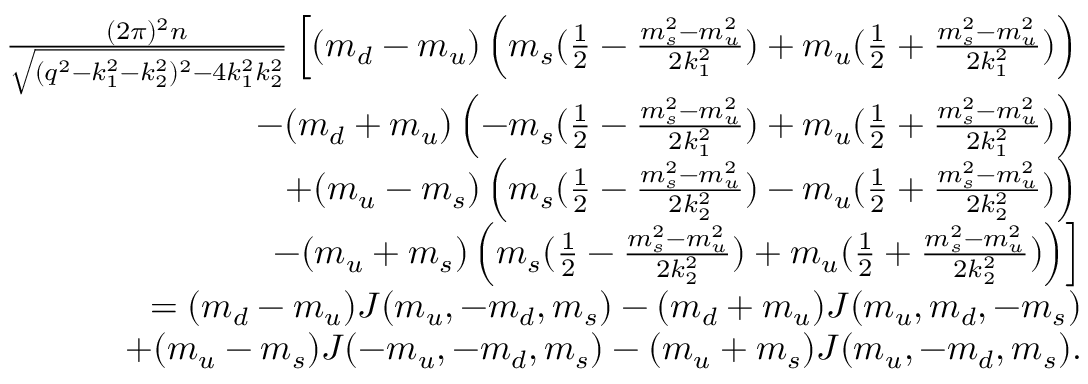<formula> <loc_0><loc_0><loc_500><loc_500>\begin{array} { r l r } & { \frac { ( 2 \pi ) ^ { 2 } n } { \sqrt { ( q ^ { 2 } - k _ { 1 } ^ { 2 } - k _ { 2 } ^ { 2 } ) ^ { 2 } - 4 k _ { 1 } ^ { 2 } k _ { 2 } ^ { 2 } } } \left [ ( m _ { d } - m _ { u } ) \left ( m _ { s } ( \frac { 1 } { 2 } - \frac { m _ { s } ^ { 2 } - m _ { u } ^ { 2 } } { 2 k _ { 1 } ^ { 2 } } ) + m _ { u } ( \frac { 1 } { 2 } + \frac { m _ { s } ^ { 2 } - m _ { u } ^ { 2 } } { 2 k _ { 1 } ^ { 2 } } ) \right ) } \\ & { - ( m _ { d } + m _ { u } ) \left ( - m _ { s } ( \frac { 1 } { 2 } - \frac { m _ { s } ^ { 2 } - m _ { u } ^ { 2 } } { 2 k _ { 1 } ^ { 2 } } ) + m _ { u } ( \frac { 1 } { 2 } + \frac { m _ { s } ^ { 2 } - m _ { u } ^ { 2 } } { 2 k _ { 1 } ^ { 2 } } ) \right ) } \\ & { + ( m _ { u } - m _ { s } ) \left ( m _ { s } ( \frac { 1 } { 2 } - \frac { m _ { s } ^ { 2 } - m _ { u } ^ { 2 } } { 2 k _ { 2 } ^ { 2 } } ) - m _ { u } ( \frac { 1 } { 2 } + \frac { m _ { s } ^ { 2 } - m _ { u } ^ { 2 } } { 2 k _ { 2 } ^ { 2 } } ) \right ) } \\ & { - ( m _ { u } + m _ { s } ) \left ( m _ { s } ( \frac { 1 } { 2 } - \frac { m _ { s } ^ { 2 } - m _ { u } ^ { 2 } } { 2 k _ { 2 } ^ { 2 } } ) + m _ { u } ( \frac { 1 } { 2 } + \frac { m _ { s } ^ { 2 } - m _ { u } ^ { 2 } } { 2 k _ { 2 } ^ { 2 } } ) \right ) \right ] } \\ & { = ( m _ { d } - m _ { u } ) J ( m _ { u } , - m _ { d } , m _ { s } ) - ( m _ { d } + m _ { u } ) J ( m _ { u } , m _ { d } , - m _ { s } ) } \\ & { + ( m _ { u } - m _ { s } ) J ( - m _ { u } , - m _ { d } , m _ { s } ) - ( m _ { u } + m _ { s } ) J ( m _ { u } , - m _ { d } , m _ { s } ) . } \end{array}</formula> 